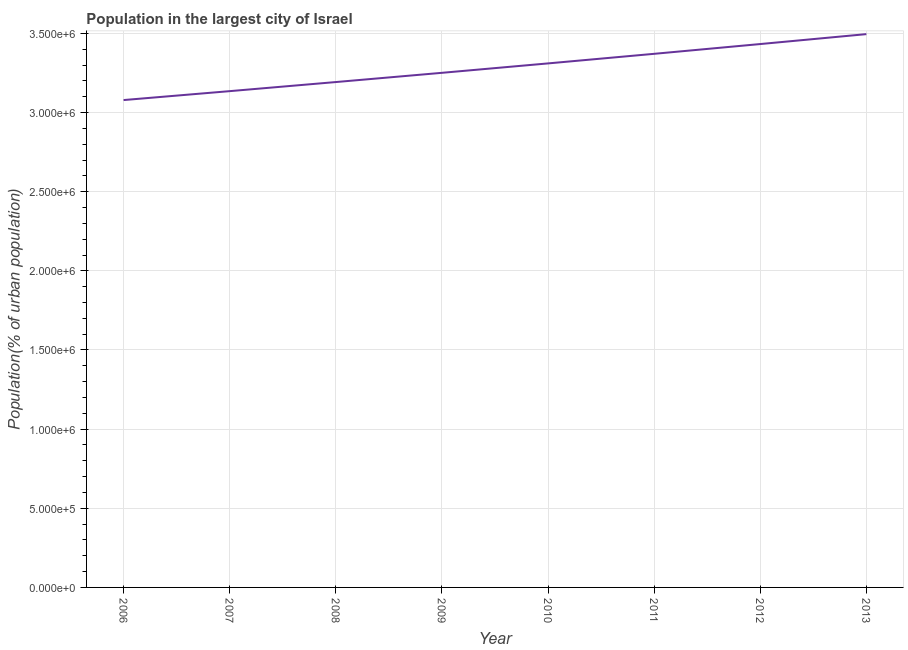What is the population in largest city in 2007?
Your response must be concise. 3.14e+06. Across all years, what is the maximum population in largest city?
Provide a succinct answer. 3.50e+06. Across all years, what is the minimum population in largest city?
Offer a very short reply. 3.08e+06. In which year was the population in largest city maximum?
Provide a succinct answer. 2013. What is the sum of the population in largest city?
Offer a very short reply. 2.63e+07. What is the difference between the population in largest city in 2007 and 2013?
Keep it short and to the point. -3.60e+05. What is the average population in largest city per year?
Offer a terse response. 3.28e+06. What is the median population in largest city?
Keep it short and to the point. 3.28e+06. In how many years, is the population in largest city greater than 900000 %?
Your answer should be compact. 8. What is the ratio of the population in largest city in 2010 to that in 2011?
Your answer should be very brief. 0.98. Is the population in largest city in 2006 less than that in 2009?
Your answer should be compact. Yes. What is the difference between the highest and the second highest population in largest city?
Your response must be concise. 6.27e+04. What is the difference between the highest and the lowest population in largest city?
Offer a terse response. 4.17e+05. In how many years, is the population in largest city greater than the average population in largest city taken over all years?
Provide a succinct answer. 4. How many lines are there?
Make the answer very short. 1. What is the difference between two consecutive major ticks on the Y-axis?
Offer a very short reply. 5.00e+05. Does the graph contain grids?
Your response must be concise. Yes. What is the title of the graph?
Provide a succinct answer. Population in the largest city of Israel. What is the label or title of the Y-axis?
Provide a succinct answer. Population(% of urban population). What is the Population(% of urban population) in 2006?
Keep it short and to the point. 3.08e+06. What is the Population(% of urban population) in 2007?
Provide a succinct answer. 3.14e+06. What is the Population(% of urban population) of 2008?
Keep it short and to the point. 3.19e+06. What is the Population(% of urban population) of 2009?
Offer a terse response. 3.25e+06. What is the Population(% of urban population) of 2010?
Provide a succinct answer. 3.31e+06. What is the Population(% of urban population) in 2011?
Your answer should be very brief. 3.37e+06. What is the Population(% of urban population) of 2012?
Provide a succinct answer. 3.43e+06. What is the Population(% of urban population) of 2013?
Make the answer very short. 3.50e+06. What is the difference between the Population(% of urban population) in 2006 and 2007?
Provide a short and direct response. -5.63e+04. What is the difference between the Population(% of urban population) in 2006 and 2008?
Your answer should be very brief. -1.14e+05. What is the difference between the Population(% of urban population) in 2006 and 2009?
Provide a short and direct response. -1.72e+05. What is the difference between the Population(% of urban population) in 2006 and 2010?
Your answer should be very brief. -2.32e+05. What is the difference between the Population(% of urban population) in 2006 and 2011?
Your answer should be compact. -2.92e+05. What is the difference between the Population(% of urban population) in 2006 and 2012?
Keep it short and to the point. -3.54e+05. What is the difference between the Population(% of urban population) in 2006 and 2013?
Offer a very short reply. -4.17e+05. What is the difference between the Population(% of urban population) in 2007 and 2008?
Provide a short and direct response. -5.74e+04. What is the difference between the Population(% of urban population) in 2007 and 2009?
Your answer should be very brief. -1.16e+05. What is the difference between the Population(% of urban population) in 2007 and 2010?
Offer a very short reply. -1.75e+05. What is the difference between the Population(% of urban population) in 2007 and 2011?
Your answer should be very brief. -2.36e+05. What is the difference between the Population(% of urban population) in 2007 and 2012?
Provide a short and direct response. -2.98e+05. What is the difference between the Population(% of urban population) in 2007 and 2013?
Provide a succinct answer. -3.60e+05. What is the difference between the Population(% of urban population) in 2008 and 2009?
Make the answer very short. -5.83e+04. What is the difference between the Population(% of urban population) in 2008 and 2010?
Ensure brevity in your answer.  -1.18e+05. What is the difference between the Population(% of urban population) in 2008 and 2011?
Provide a succinct answer. -1.78e+05. What is the difference between the Population(% of urban population) in 2008 and 2012?
Your answer should be compact. -2.40e+05. What is the difference between the Population(% of urban population) in 2008 and 2013?
Your response must be concise. -3.03e+05. What is the difference between the Population(% of urban population) in 2009 and 2010?
Ensure brevity in your answer.  -5.95e+04. What is the difference between the Population(% of urban population) in 2009 and 2011?
Your response must be concise. -1.20e+05. What is the difference between the Population(% of urban population) in 2009 and 2012?
Provide a short and direct response. -1.82e+05. What is the difference between the Population(% of urban population) in 2009 and 2013?
Your answer should be compact. -2.44e+05. What is the difference between the Population(% of urban population) in 2010 and 2011?
Make the answer very short. -6.06e+04. What is the difference between the Population(% of urban population) in 2010 and 2012?
Ensure brevity in your answer.  -1.22e+05. What is the difference between the Population(% of urban population) in 2010 and 2013?
Give a very brief answer. -1.85e+05. What is the difference between the Population(% of urban population) in 2011 and 2012?
Keep it short and to the point. -6.18e+04. What is the difference between the Population(% of urban population) in 2011 and 2013?
Provide a succinct answer. -1.24e+05. What is the difference between the Population(% of urban population) in 2012 and 2013?
Make the answer very short. -6.27e+04. What is the ratio of the Population(% of urban population) in 2006 to that in 2007?
Offer a very short reply. 0.98. What is the ratio of the Population(% of urban population) in 2006 to that in 2008?
Make the answer very short. 0.96. What is the ratio of the Population(% of urban population) in 2006 to that in 2009?
Offer a terse response. 0.95. What is the ratio of the Population(% of urban population) in 2006 to that in 2011?
Keep it short and to the point. 0.91. What is the ratio of the Population(% of urban population) in 2006 to that in 2012?
Your response must be concise. 0.9. What is the ratio of the Population(% of urban population) in 2006 to that in 2013?
Provide a succinct answer. 0.88. What is the ratio of the Population(% of urban population) in 2007 to that in 2009?
Your answer should be compact. 0.96. What is the ratio of the Population(% of urban population) in 2007 to that in 2010?
Give a very brief answer. 0.95. What is the ratio of the Population(% of urban population) in 2007 to that in 2011?
Make the answer very short. 0.93. What is the ratio of the Population(% of urban population) in 2007 to that in 2012?
Provide a succinct answer. 0.91. What is the ratio of the Population(% of urban population) in 2007 to that in 2013?
Provide a short and direct response. 0.9. What is the ratio of the Population(% of urban population) in 2008 to that in 2010?
Ensure brevity in your answer.  0.96. What is the ratio of the Population(% of urban population) in 2008 to that in 2011?
Make the answer very short. 0.95. What is the ratio of the Population(% of urban population) in 2009 to that in 2012?
Make the answer very short. 0.95. What is the ratio of the Population(% of urban population) in 2009 to that in 2013?
Keep it short and to the point. 0.93. What is the ratio of the Population(% of urban population) in 2010 to that in 2011?
Make the answer very short. 0.98. What is the ratio of the Population(% of urban population) in 2010 to that in 2012?
Your response must be concise. 0.96. What is the ratio of the Population(% of urban population) in 2010 to that in 2013?
Your answer should be very brief. 0.95. What is the ratio of the Population(% of urban population) in 2012 to that in 2013?
Your answer should be compact. 0.98. 